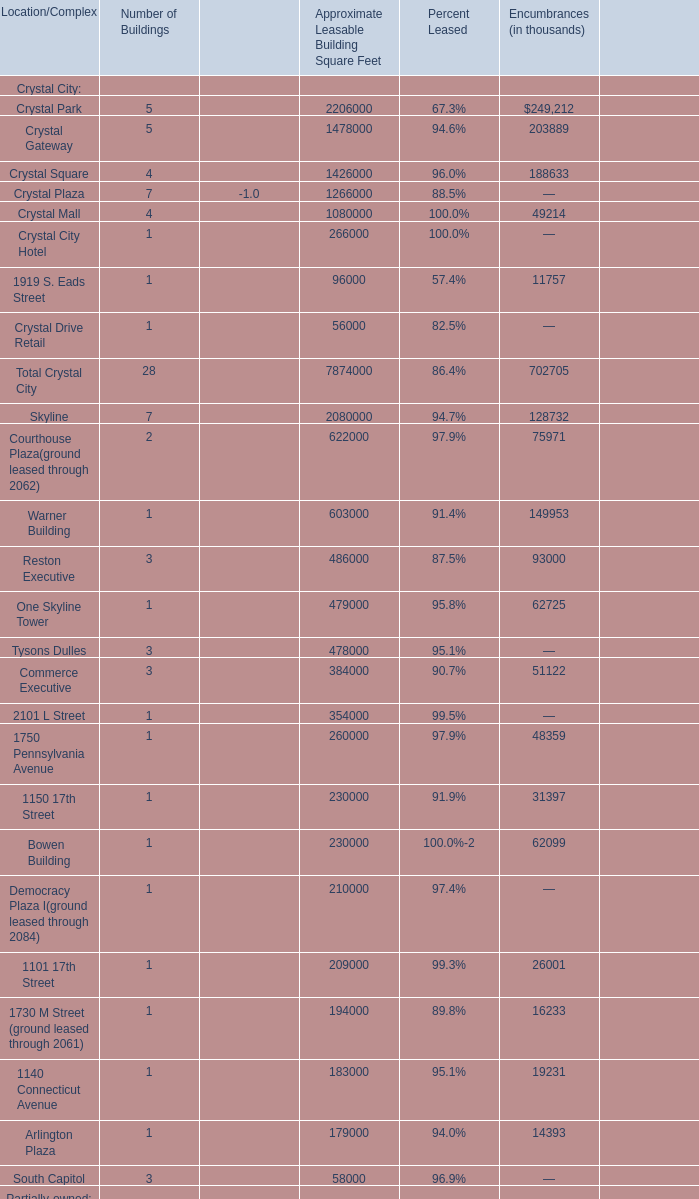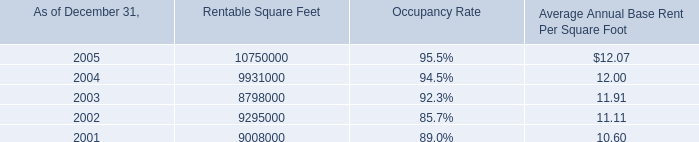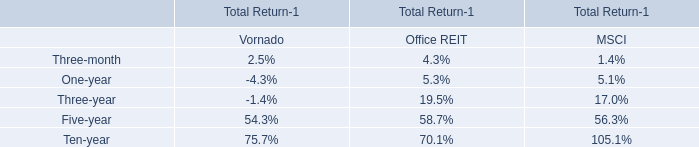What is the average Number of Buildings in terms of Crystal City Hotel and Crystal Drive Retail? 
Computations: ((1 + 1) / 2)
Answer: 1.0. 